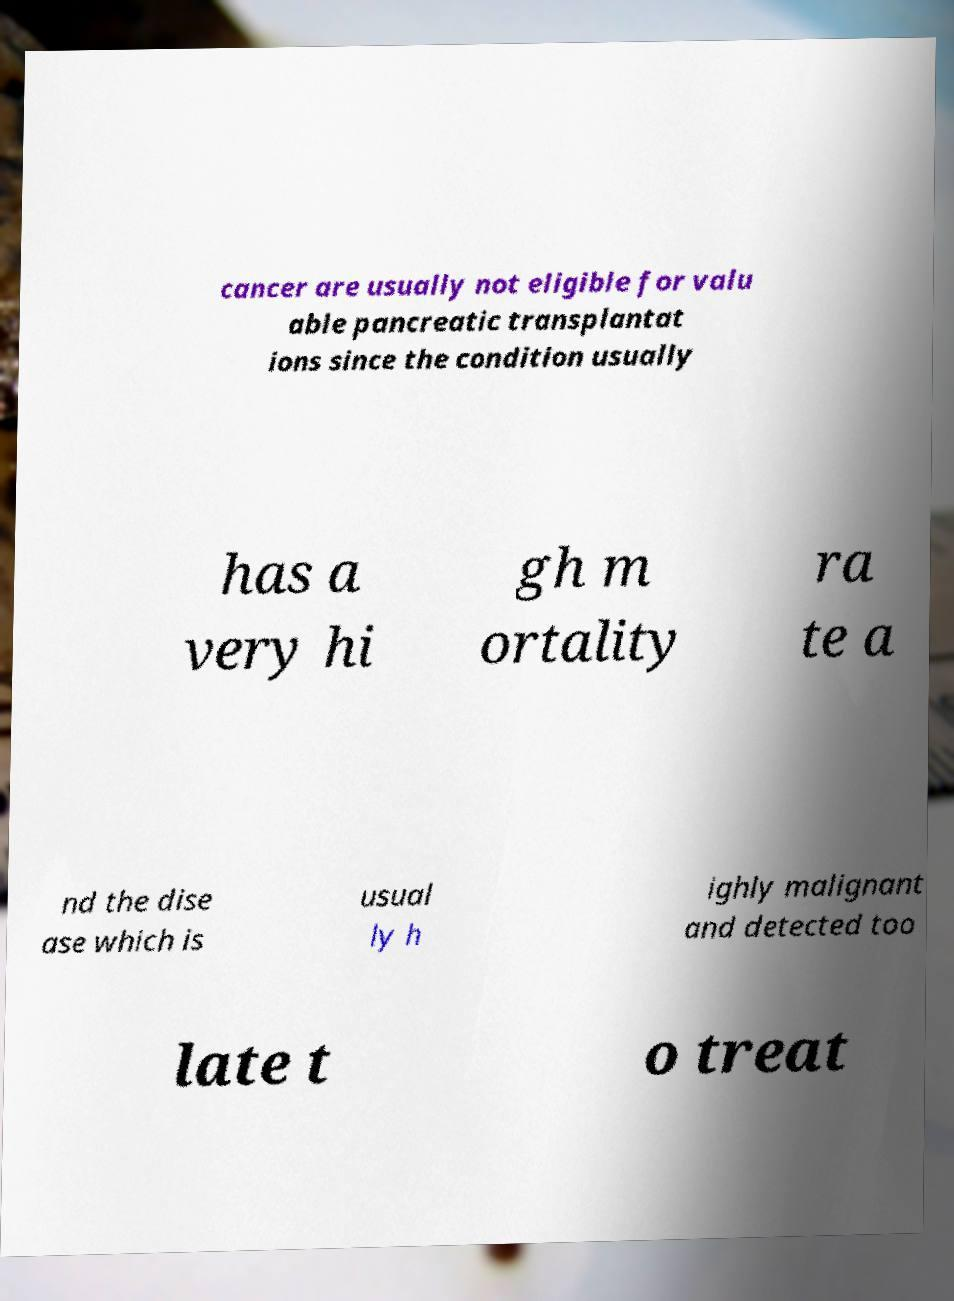Please read and relay the text visible in this image. What does it say? cancer are usually not eligible for valu able pancreatic transplantat ions since the condition usually has a very hi gh m ortality ra te a nd the dise ase which is usual ly h ighly malignant and detected too late t o treat 